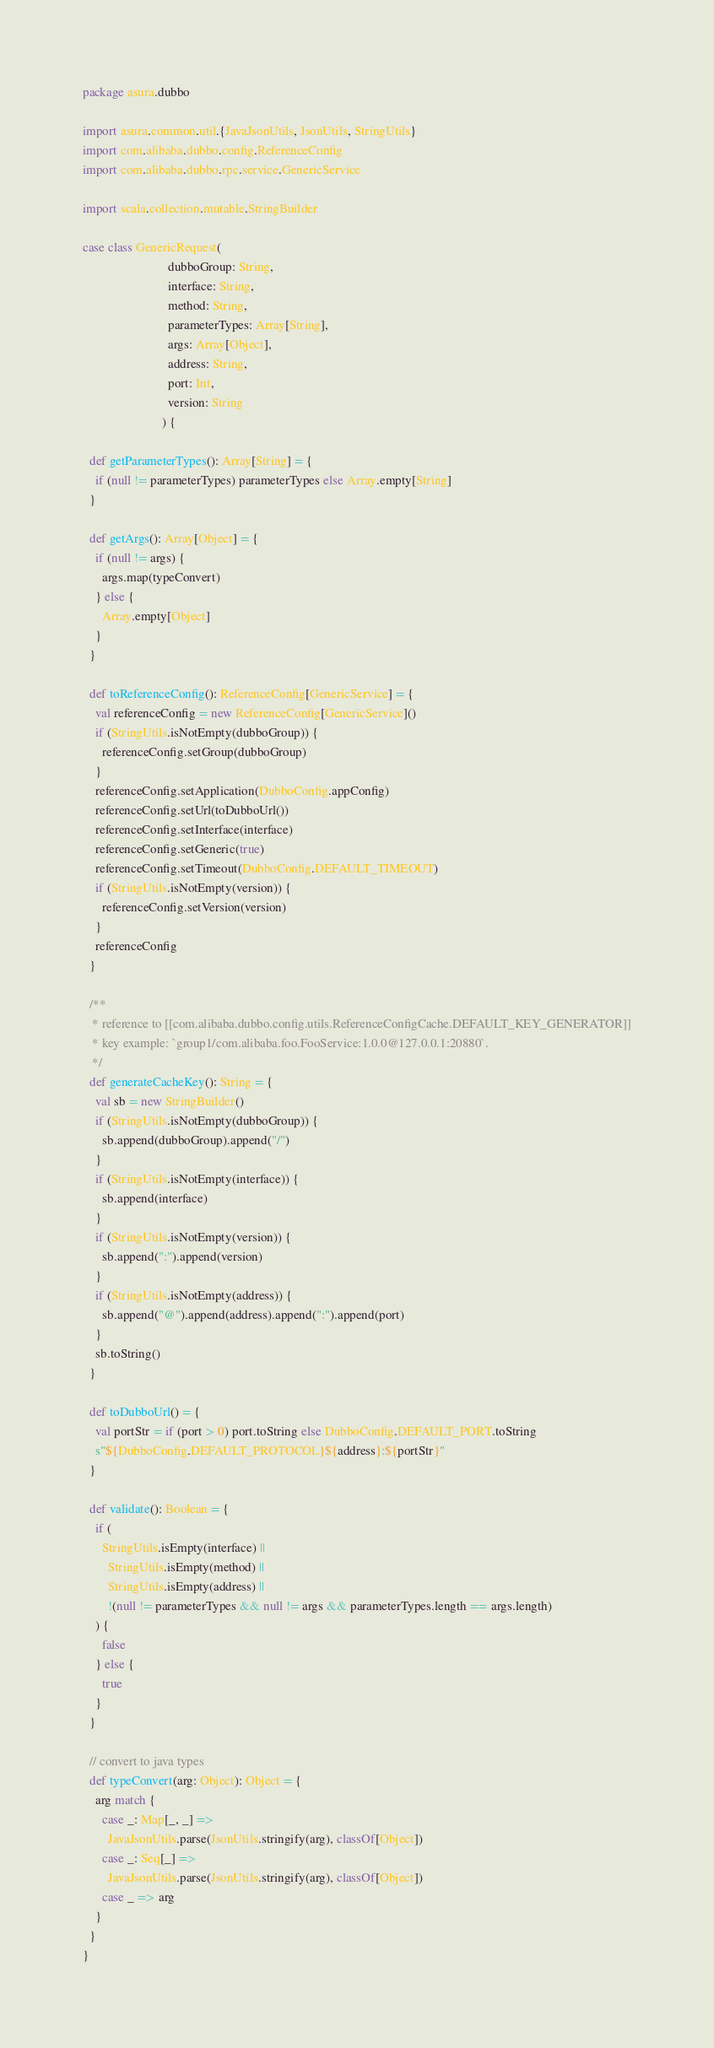<code> <loc_0><loc_0><loc_500><loc_500><_Scala_>package asura.dubbo

import asura.common.util.{JavaJsonUtils, JsonUtils, StringUtils}
import com.alibaba.dubbo.config.ReferenceConfig
import com.alibaba.dubbo.rpc.service.GenericService

import scala.collection.mutable.StringBuilder

case class GenericRequest(
                           dubboGroup: String,
                           interface: String,
                           method: String,
                           parameterTypes: Array[String],
                           args: Array[Object],
                           address: String,
                           port: Int,
                           version: String
                         ) {

  def getParameterTypes(): Array[String] = {
    if (null != parameterTypes) parameterTypes else Array.empty[String]
  }

  def getArgs(): Array[Object] = {
    if (null != args) {
      args.map(typeConvert)
    } else {
      Array.empty[Object]
    }
  }

  def toReferenceConfig(): ReferenceConfig[GenericService] = {
    val referenceConfig = new ReferenceConfig[GenericService]()
    if (StringUtils.isNotEmpty(dubboGroup)) {
      referenceConfig.setGroup(dubboGroup)
    }
    referenceConfig.setApplication(DubboConfig.appConfig)
    referenceConfig.setUrl(toDubboUrl())
    referenceConfig.setInterface(interface)
    referenceConfig.setGeneric(true)
    referenceConfig.setTimeout(DubboConfig.DEFAULT_TIMEOUT)
    if (StringUtils.isNotEmpty(version)) {
      referenceConfig.setVersion(version)
    }
    referenceConfig
  }

  /**
   * reference to [[com.alibaba.dubbo.config.utils.ReferenceConfigCache.DEFAULT_KEY_GENERATOR]]
   * key example: `group1/com.alibaba.foo.FooService:1.0.0@127.0.0.1:20880`.
   */
  def generateCacheKey(): String = {
    val sb = new StringBuilder()
    if (StringUtils.isNotEmpty(dubboGroup)) {
      sb.append(dubboGroup).append("/")
    }
    if (StringUtils.isNotEmpty(interface)) {
      sb.append(interface)
    }
    if (StringUtils.isNotEmpty(version)) {
      sb.append(":").append(version)
    }
    if (StringUtils.isNotEmpty(address)) {
      sb.append("@").append(address).append(":").append(port)
    }
    sb.toString()
  }

  def toDubboUrl() = {
    val portStr = if (port > 0) port.toString else DubboConfig.DEFAULT_PORT.toString
    s"${DubboConfig.DEFAULT_PROTOCOL}${address}:${portStr}"
  }

  def validate(): Boolean = {
    if (
      StringUtils.isEmpty(interface) ||
        StringUtils.isEmpty(method) ||
        StringUtils.isEmpty(address) ||
        !(null != parameterTypes && null != args && parameterTypes.length == args.length)
    ) {
      false
    } else {
      true
    }
  }

  // convert to java types
  def typeConvert(arg: Object): Object = {
    arg match {
      case _: Map[_, _] =>
        JavaJsonUtils.parse(JsonUtils.stringify(arg), classOf[Object])
      case _: Seq[_] =>
        JavaJsonUtils.parse(JsonUtils.stringify(arg), classOf[Object])
      case _ => arg
    }
  }
}
</code> 